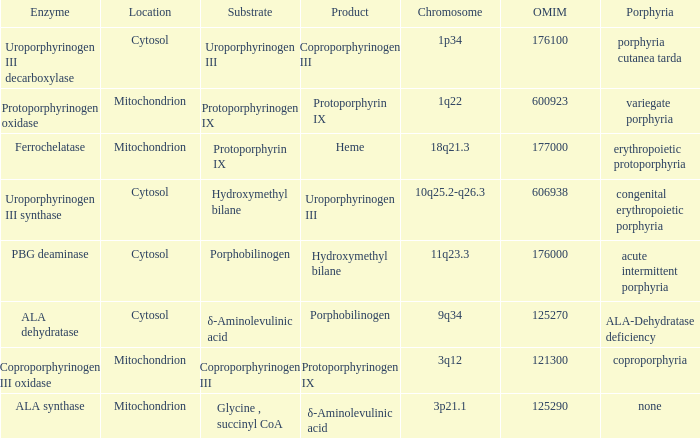What is protoporphyrin ix's substrate? Protoporphyrinogen IX. 